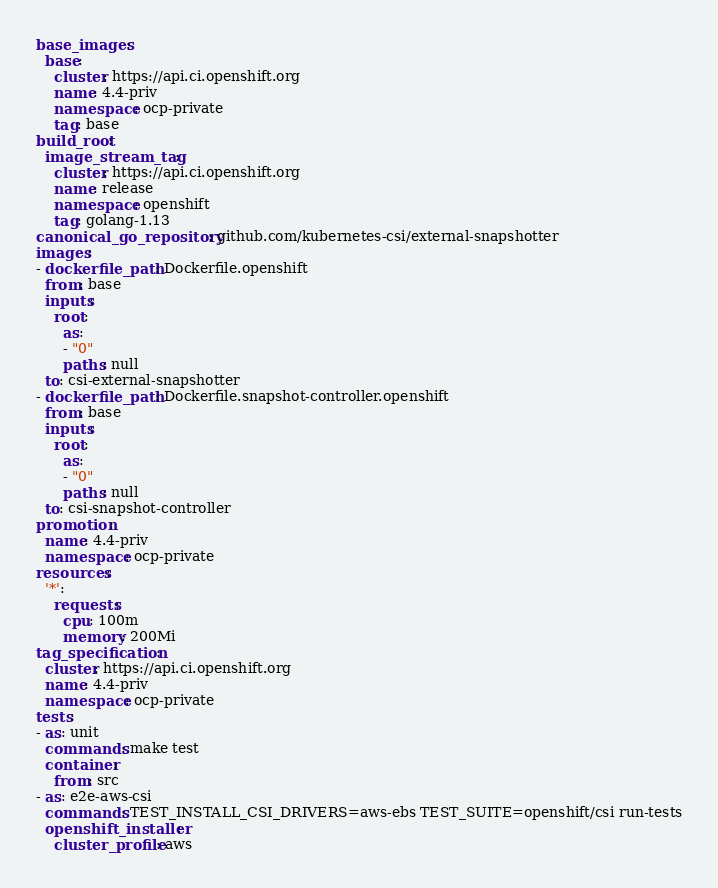<code> <loc_0><loc_0><loc_500><loc_500><_YAML_>base_images:
  base:
    cluster: https://api.ci.openshift.org
    name: 4.4-priv
    namespace: ocp-private
    tag: base
build_root:
  image_stream_tag:
    cluster: https://api.ci.openshift.org
    name: release
    namespace: openshift
    tag: golang-1.13
canonical_go_repository: github.com/kubernetes-csi/external-snapshotter
images:
- dockerfile_path: Dockerfile.openshift
  from: base
  inputs:
    root:
      as:
      - "0"
      paths: null
  to: csi-external-snapshotter
- dockerfile_path: Dockerfile.snapshot-controller.openshift
  from: base
  inputs:
    root:
      as:
      - "0"
      paths: null
  to: csi-snapshot-controller
promotion:
  name: 4.4-priv
  namespace: ocp-private
resources:
  '*':
    requests:
      cpu: 100m
      memory: 200Mi
tag_specification:
  cluster: https://api.ci.openshift.org
  name: 4.4-priv
  namespace: ocp-private
tests:
- as: unit
  commands: make test
  container:
    from: src
- as: e2e-aws-csi
  commands: TEST_INSTALL_CSI_DRIVERS=aws-ebs TEST_SUITE=openshift/csi run-tests
  openshift_installer:
    cluster_profile: aws
</code> 